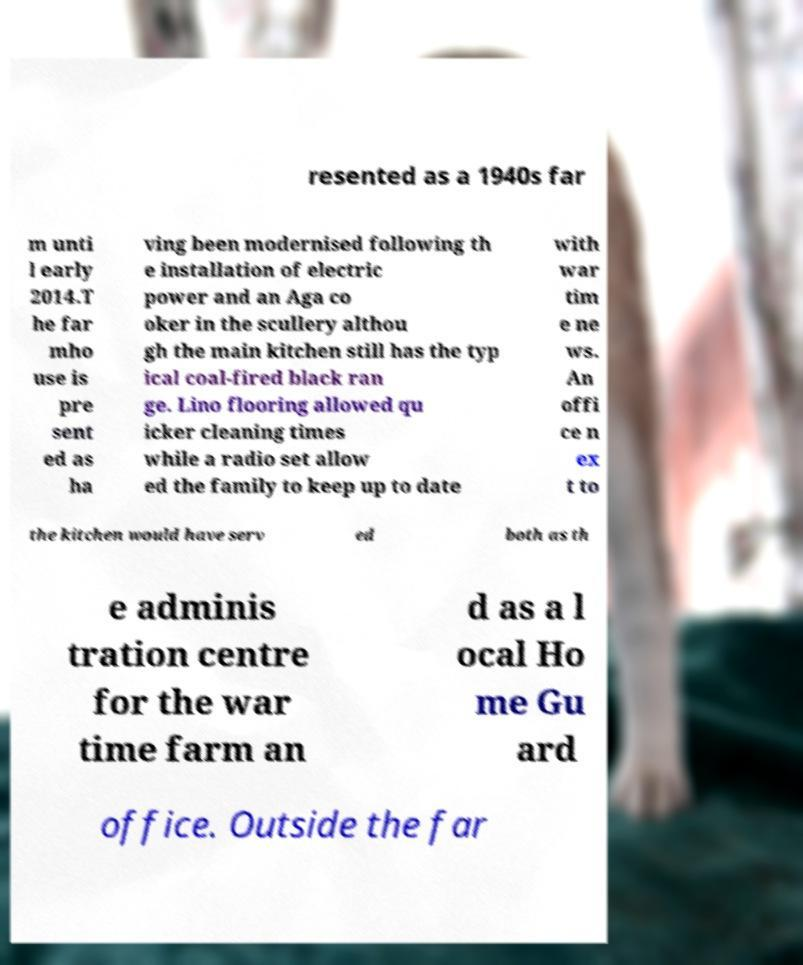There's text embedded in this image that I need extracted. Can you transcribe it verbatim? resented as a 1940s far m unti l early 2014.T he far mho use is pre sent ed as ha ving been modernised following th e installation of electric power and an Aga co oker in the scullery althou gh the main kitchen still has the typ ical coal-fired black ran ge. Lino flooring allowed qu icker cleaning times while a radio set allow ed the family to keep up to date with war tim e ne ws. An offi ce n ex t to the kitchen would have serv ed both as th e adminis tration centre for the war time farm an d as a l ocal Ho me Gu ard office. Outside the far 